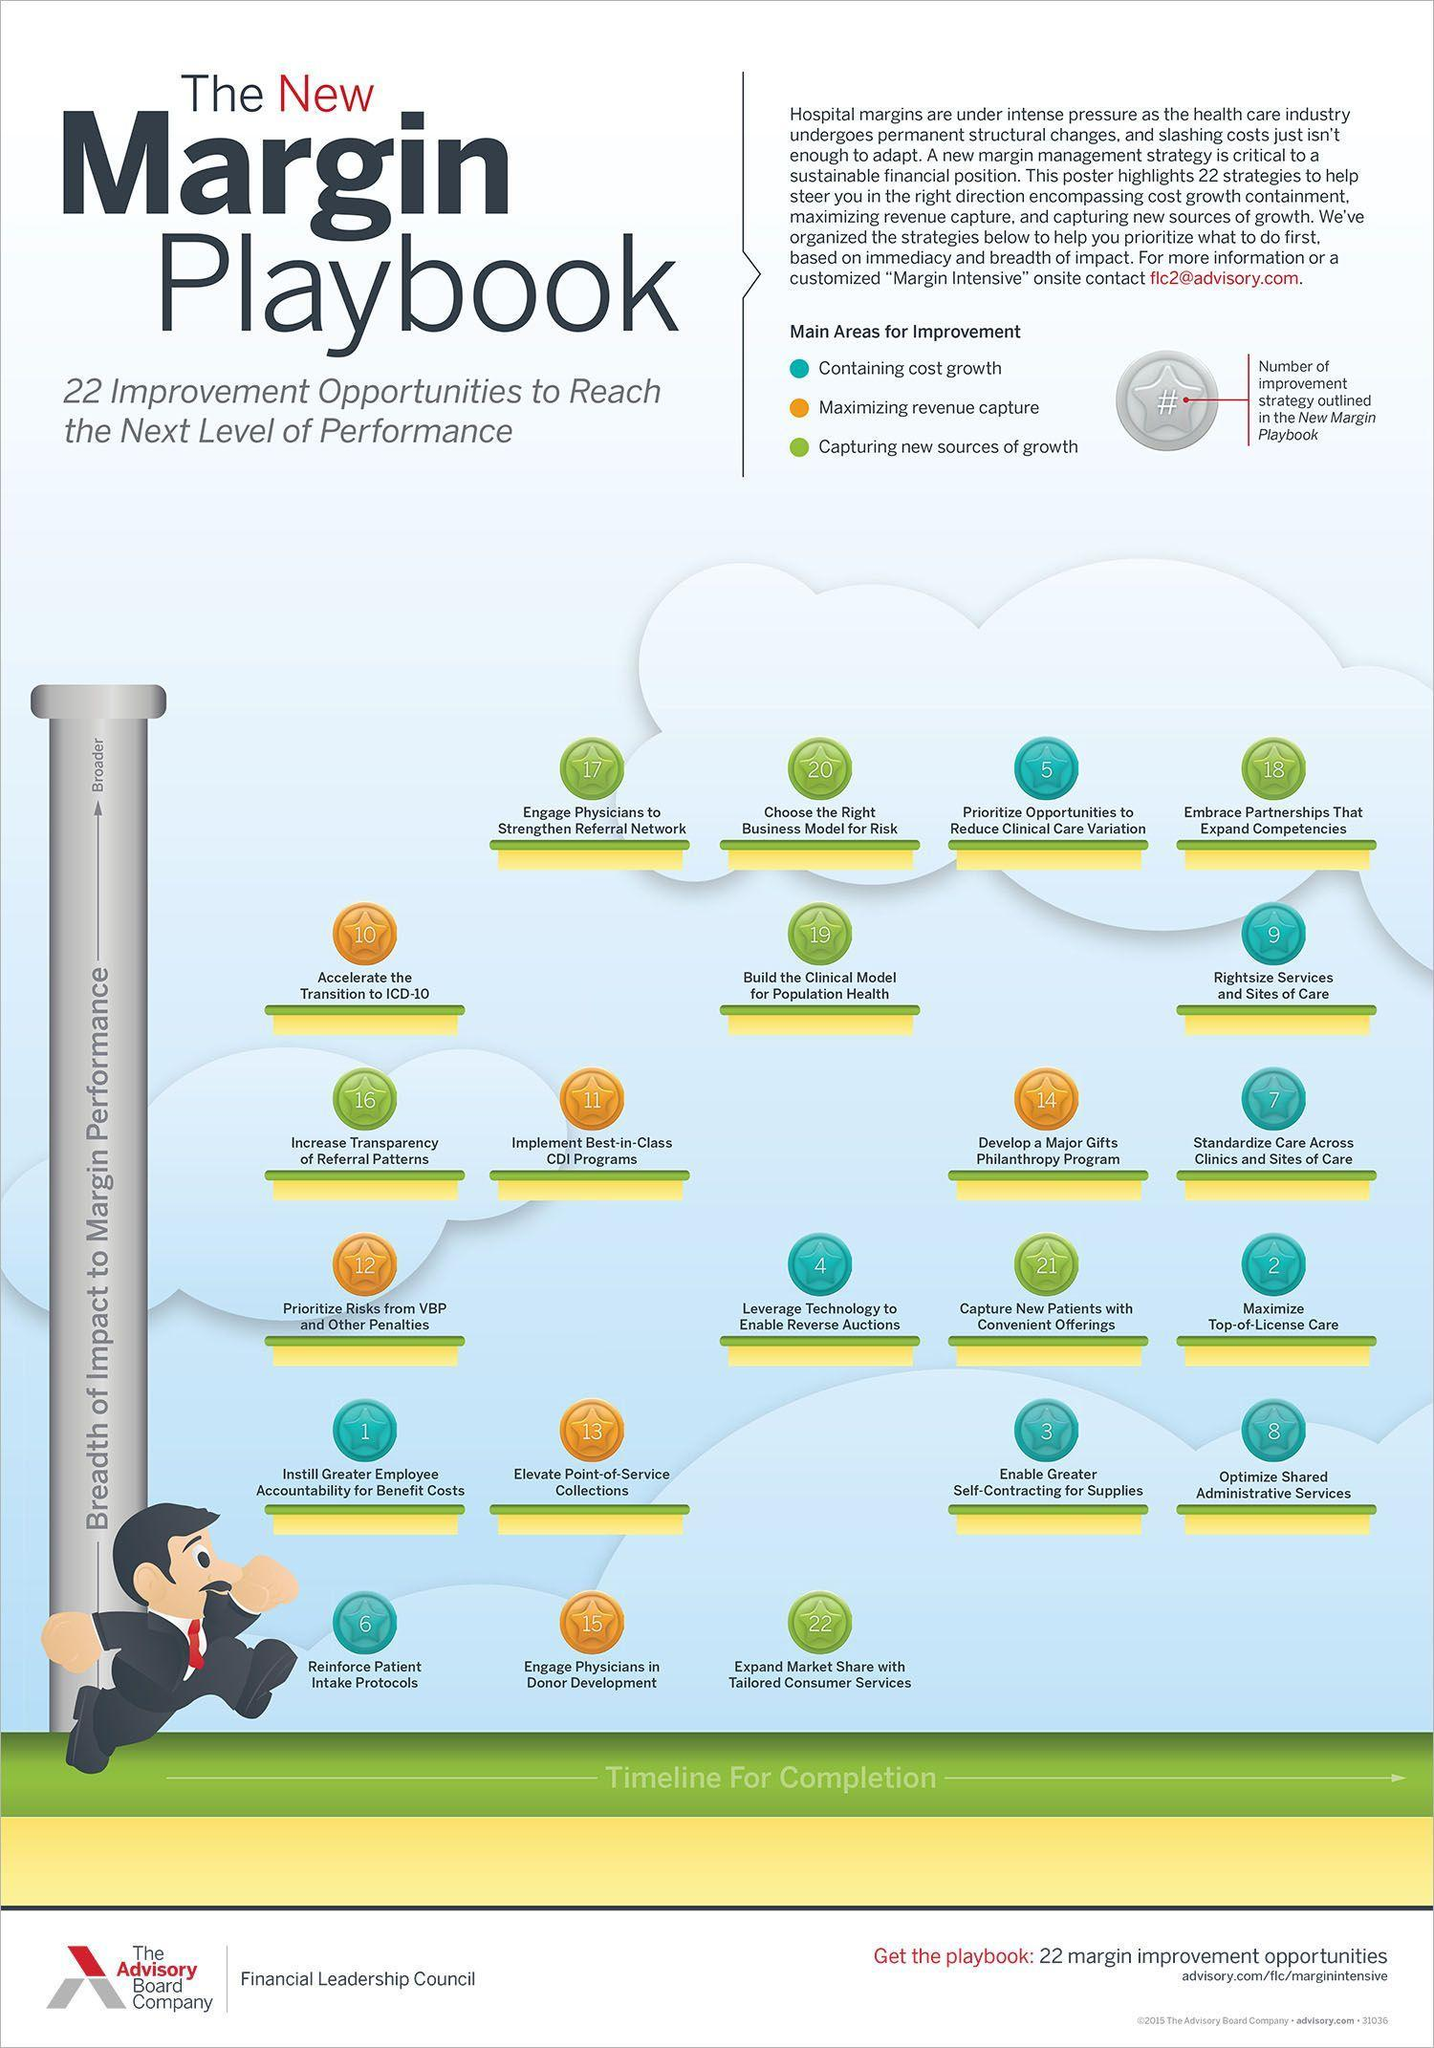Which area got the number of improvements as 1?
Answer the question with a short phrase. Instil Greater Employee Accountability for benefit costs Which area got the number of improvements as 6? Reinforce patient Intake protocols Which area got the number of improvements as 13? Elevate Point-of-Service Collections Which area got the number of improvements as 2? Maximize Top-of-License care Which color used to represent "Maximizing revenue capture"-blue, green, orange, red? orange 